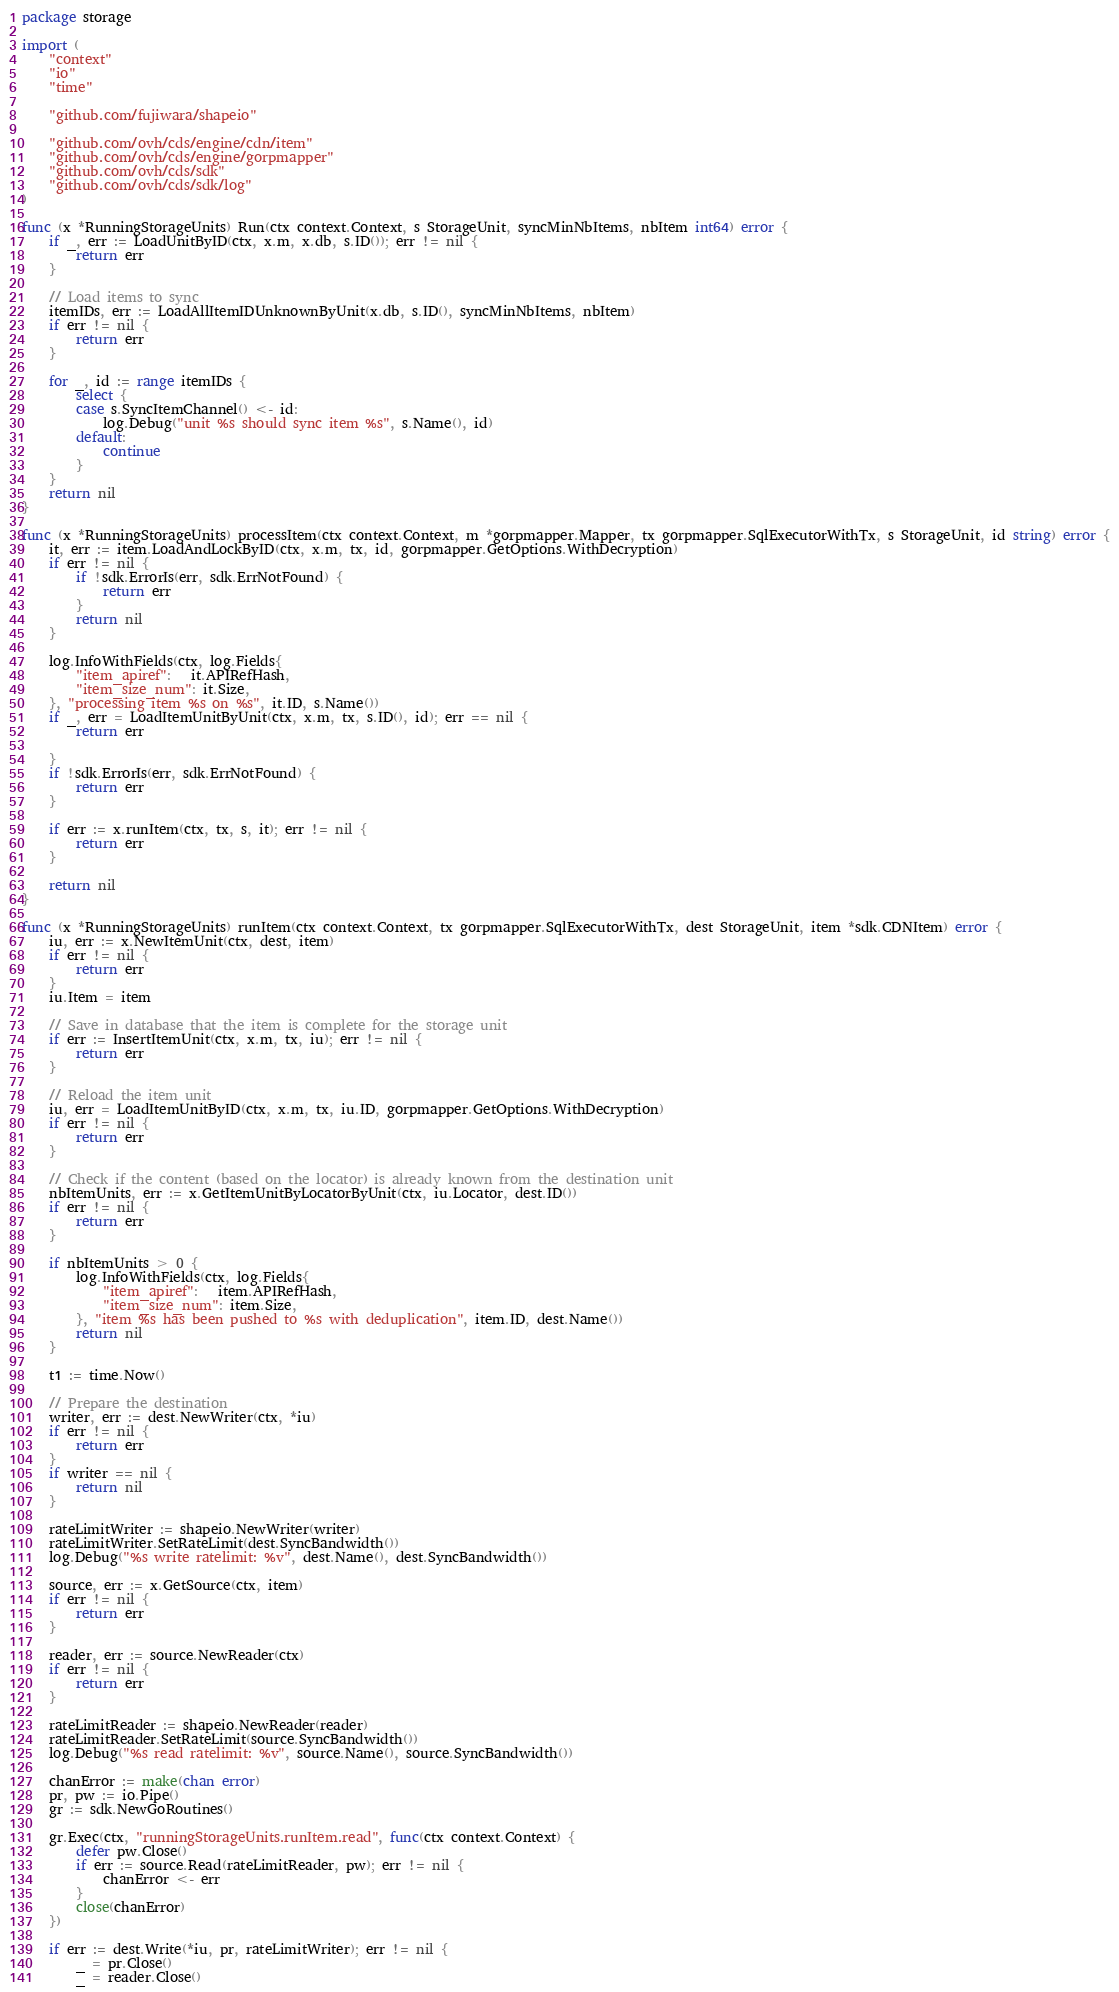<code> <loc_0><loc_0><loc_500><loc_500><_Go_>package storage

import (
	"context"
	"io"
	"time"

	"github.com/fujiwara/shapeio"

	"github.com/ovh/cds/engine/cdn/item"
	"github.com/ovh/cds/engine/gorpmapper"
	"github.com/ovh/cds/sdk"
	"github.com/ovh/cds/sdk/log"
)

func (x *RunningStorageUnits) Run(ctx context.Context, s StorageUnit, syncMinNbItems, nbItem int64) error {
	if _, err := LoadUnitByID(ctx, x.m, x.db, s.ID()); err != nil {
		return err
	}

	// Load items to sync
	itemIDs, err := LoadAllItemIDUnknownByUnit(x.db, s.ID(), syncMinNbItems, nbItem)
	if err != nil {
		return err
	}

	for _, id := range itemIDs {
		select {
		case s.SyncItemChannel() <- id:
			log.Debug("unit %s should sync item %s", s.Name(), id)
		default:
			continue
		}
	}
	return nil
}

func (x *RunningStorageUnits) processItem(ctx context.Context, m *gorpmapper.Mapper, tx gorpmapper.SqlExecutorWithTx, s StorageUnit, id string) error {
	it, err := item.LoadAndLockByID(ctx, x.m, tx, id, gorpmapper.GetOptions.WithDecryption)
	if err != nil {
		if !sdk.ErrorIs(err, sdk.ErrNotFound) {
			return err
		}
		return nil
	}

	log.InfoWithFields(ctx, log.Fields{
		"item_apiref":   it.APIRefHash,
		"item_size_num": it.Size,
	}, "processing item %s on %s", it.ID, s.Name())
	if _, err = LoadItemUnitByUnit(ctx, x.m, tx, s.ID(), id); err == nil {
		return err

	}
	if !sdk.ErrorIs(err, sdk.ErrNotFound) {
		return err
	}

	if err := x.runItem(ctx, tx, s, it); err != nil {
		return err
	}

	return nil
}

func (x *RunningStorageUnits) runItem(ctx context.Context, tx gorpmapper.SqlExecutorWithTx, dest StorageUnit, item *sdk.CDNItem) error {
	iu, err := x.NewItemUnit(ctx, dest, item)
	if err != nil {
		return err
	}
	iu.Item = item

	// Save in database that the item is complete for the storage unit
	if err := InsertItemUnit(ctx, x.m, tx, iu); err != nil {
		return err
	}

	// Reload the item unit
	iu, err = LoadItemUnitByID(ctx, x.m, tx, iu.ID, gorpmapper.GetOptions.WithDecryption)
	if err != nil {
		return err
	}

	// Check if the content (based on the locator) is already known from the destination unit
	nbItemUnits, err := x.GetItemUnitByLocatorByUnit(ctx, iu.Locator, dest.ID())
	if err != nil {
		return err
	}

	if nbItemUnits > 0 {
		log.InfoWithFields(ctx, log.Fields{
			"item_apiref":   item.APIRefHash,
			"item_size_num": item.Size,
		}, "item %s has been pushed to %s with deduplication", item.ID, dest.Name())
		return nil
	}

	t1 := time.Now()

	// Prepare the destination
	writer, err := dest.NewWriter(ctx, *iu)
	if err != nil {
		return err
	}
	if writer == nil {
		return nil
	}

	rateLimitWriter := shapeio.NewWriter(writer)
	rateLimitWriter.SetRateLimit(dest.SyncBandwidth())
	log.Debug("%s write ratelimit: %v", dest.Name(), dest.SyncBandwidth())

	source, err := x.GetSource(ctx, item)
	if err != nil {
		return err
	}

	reader, err := source.NewReader(ctx)
	if err != nil {
		return err
	}

	rateLimitReader := shapeio.NewReader(reader)
	rateLimitReader.SetRateLimit(source.SyncBandwidth())
	log.Debug("%s read ratelimit: %v", source.Name(), source.SyncBandwidth())

	chanError := make(chan error)
	pr, pw := io.Pipe()
	gr := sdk.NewGoRoutines()

	gr.Exec(ctx, "runningStorageUnits.runItem.read", func(ctx context.Context) {
		defer pw.Close()
		if err := source.Read(rateLimitReader, pw); err != nil {
			chanError <- err
		}
		close(chanError)
	})

	if err := dest.Write(*iu, pr, rateLimitWriter); err != nil {
		_ = pr.Close()
		_ = reader.Close()</code> 